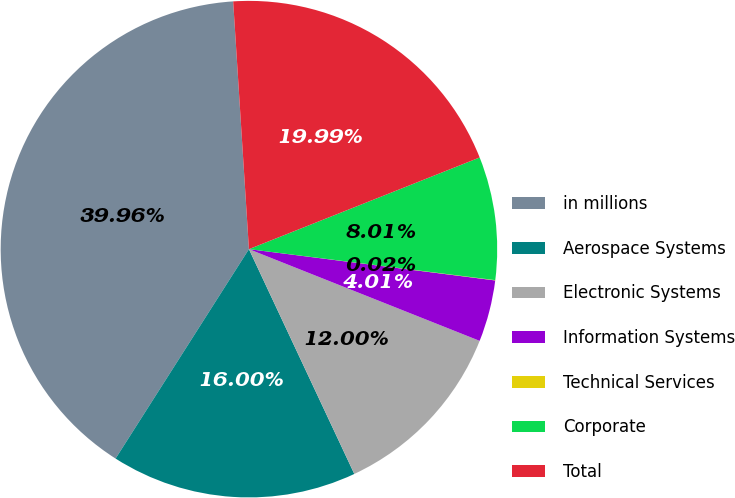<chart> <loc_0><loc_0><loc_500><loc_500><pie_chart><fcel>in millions<fcel>Aerospace Systems<fcel>Electronic Systems<fcel>Information Systems<fcel>Technical Services<fcel>Corporate<fcel>Total<nl><fcel>39.96%<fcel>16.0%<fcel>12.0%<fcel>4.01%<fcel>0.02%<fcel>8.01%<fcel>19.99%<nl></chart> 